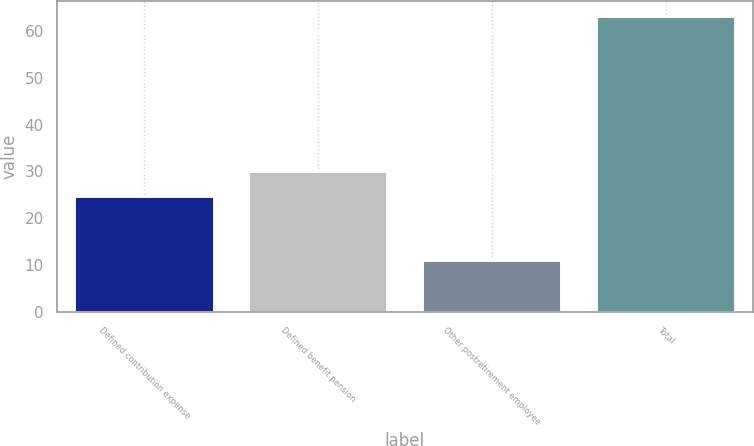Convert chart. <chart><loc_0><loc_0><loc_500><loc_500><bar_chart><fcel>Defined contribution expense<fcel>Defined benefit pension<fcel>Other postretirement employee<fcel>Total<nl><fcel>24.8<fcel>30.01<fcel>11.1<fcel>63.2<nl></chart> 